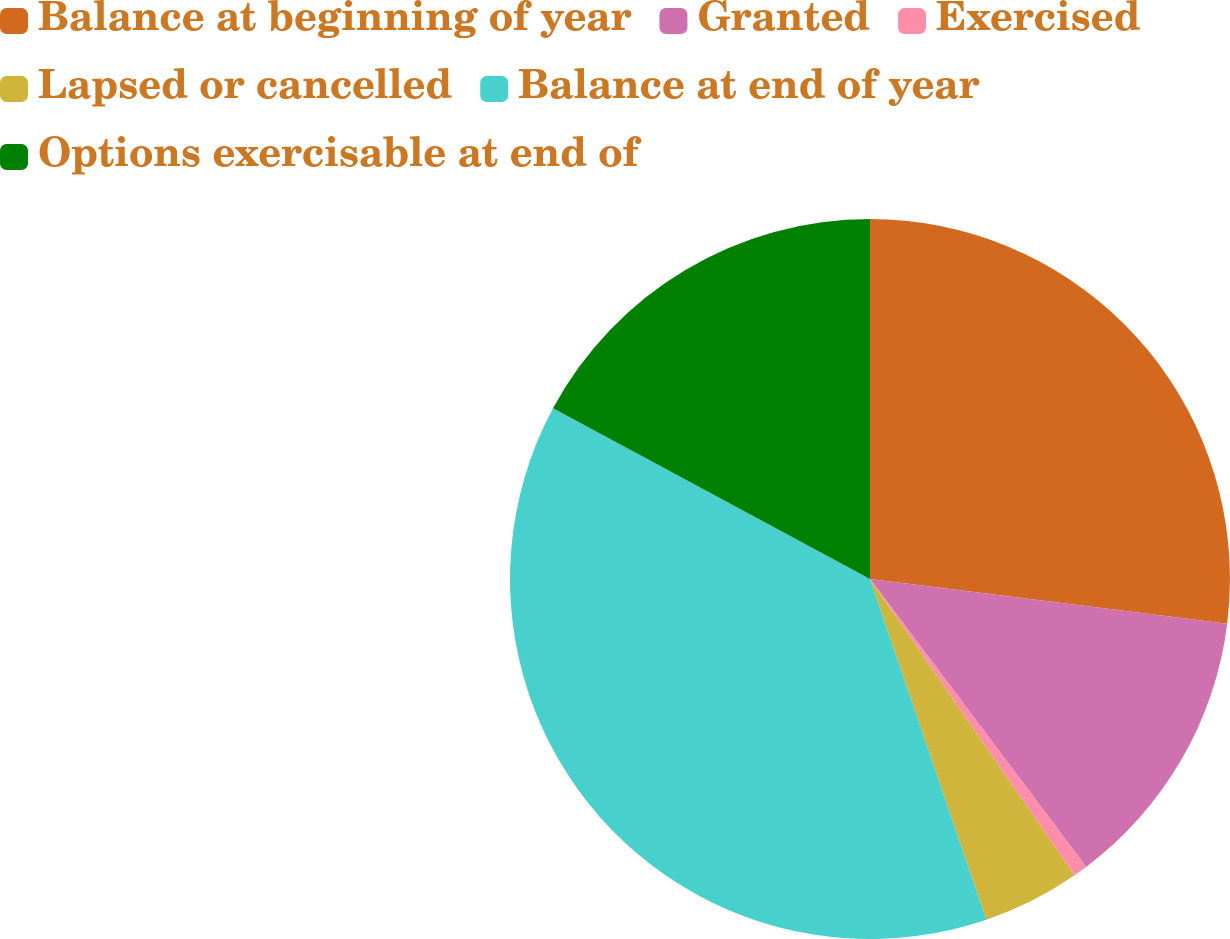Convert chart to OTSL. <chart><loc_0><loc_0><loc_500><loc_500><pie_chart><fcel>Balance at beginning of year<fcel>Granted<fcel>Exercised<fcel>Lapsed or cancelled<fcel>Balance at end of year<fcel>Options exercisable at end of<nl><fcel>26.98%<fcel>12.77%<fcel>0.63%<fcel>4.38%<fcel>38.1%<fcel>17.14%<nl></chart> 